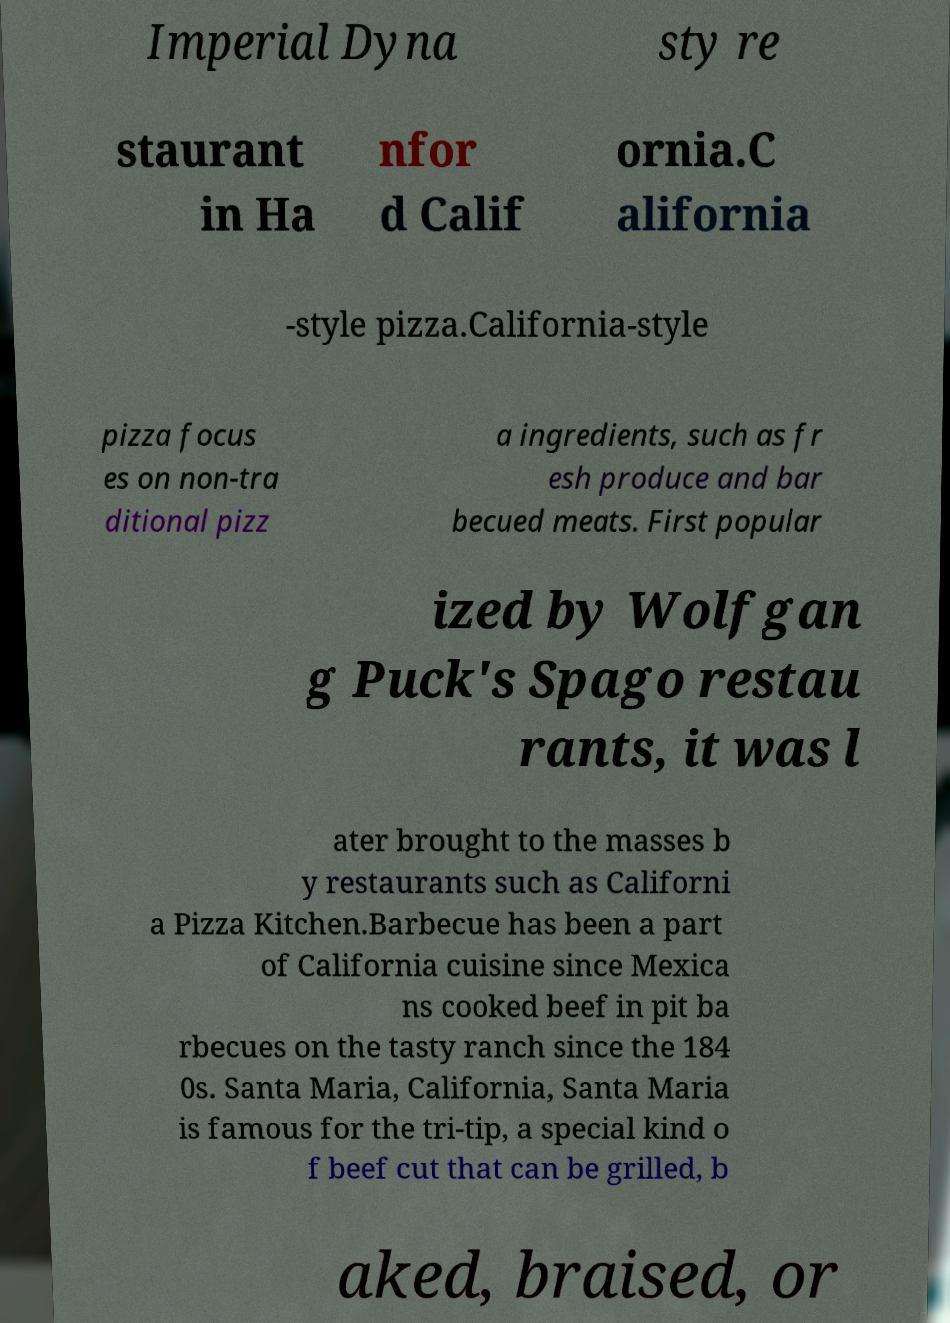What messages or text are displayed in this image? I need them in a readable, typed format. Imperial Dyna sty re staurant in Ha nfor d Calif ornia.C alifornia -style pizza.California-style pizza focus es on non-tra ditional pizz a ingredients, such as fr esh produce and bar becued meats. First popular ized by Wolfgan g Puck's Spago restau rants, it was l ater brought to the masses b y restaurants such as Californi a Pizza Kitchen.Barbecue has been a part of California cuisine since Mexica ns cooked beef in pit ba rbecues on the tasty ranch since the 184 0s. Santa Maria, California, Santa Maria is famous for the tri-tip, a special kind o f beef cut that can be grilled, b aked, braised, or 